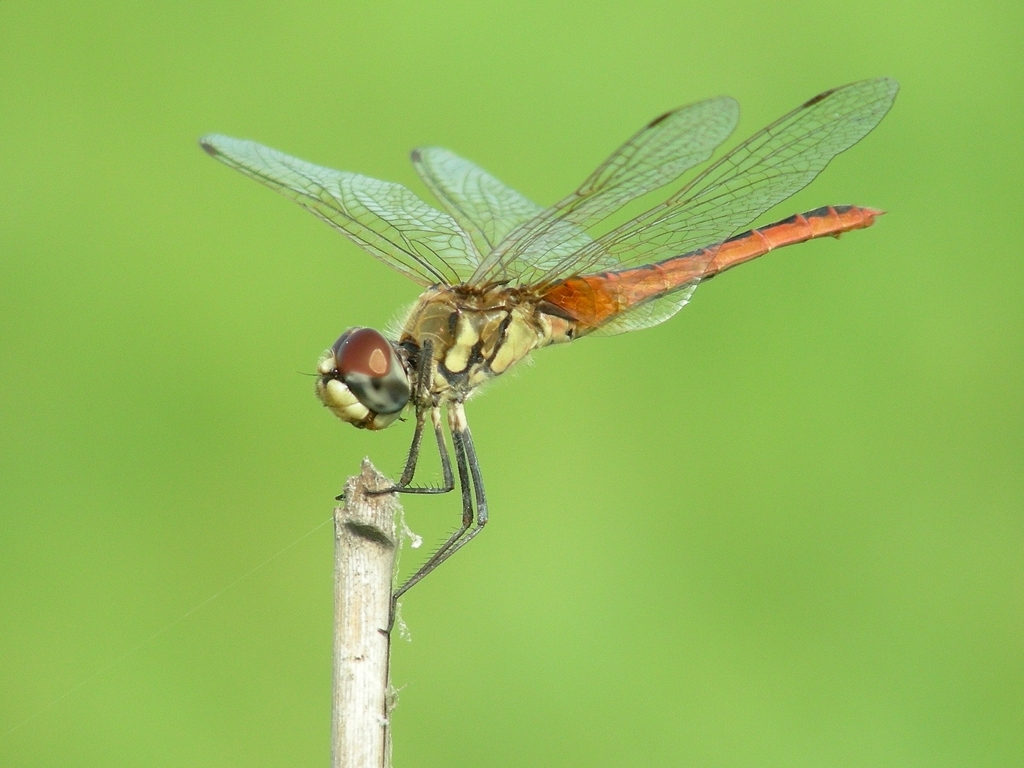Can you tell me about the habitat preferences of this dragonfly? This dragonfly appears to be perched on a stem, suggesting a preference for marshy or wetland areas where they can find abundant prey and suitable breeding sites. They thrive in a variety of aquatic habitats and are indicators of a healthy environment. 